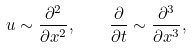Convert formula to latex. <formula><loc_0><loc_0><loc_500><loc_500>u \sim \frac { \partial ^ { 2 } } { \partial x ^ { 2 } } , \quad \frac { \partial } { \partial t } \sim \frac { \partial ^ { 3 } } { \partial x ^ { 3 } } ,</formula> 